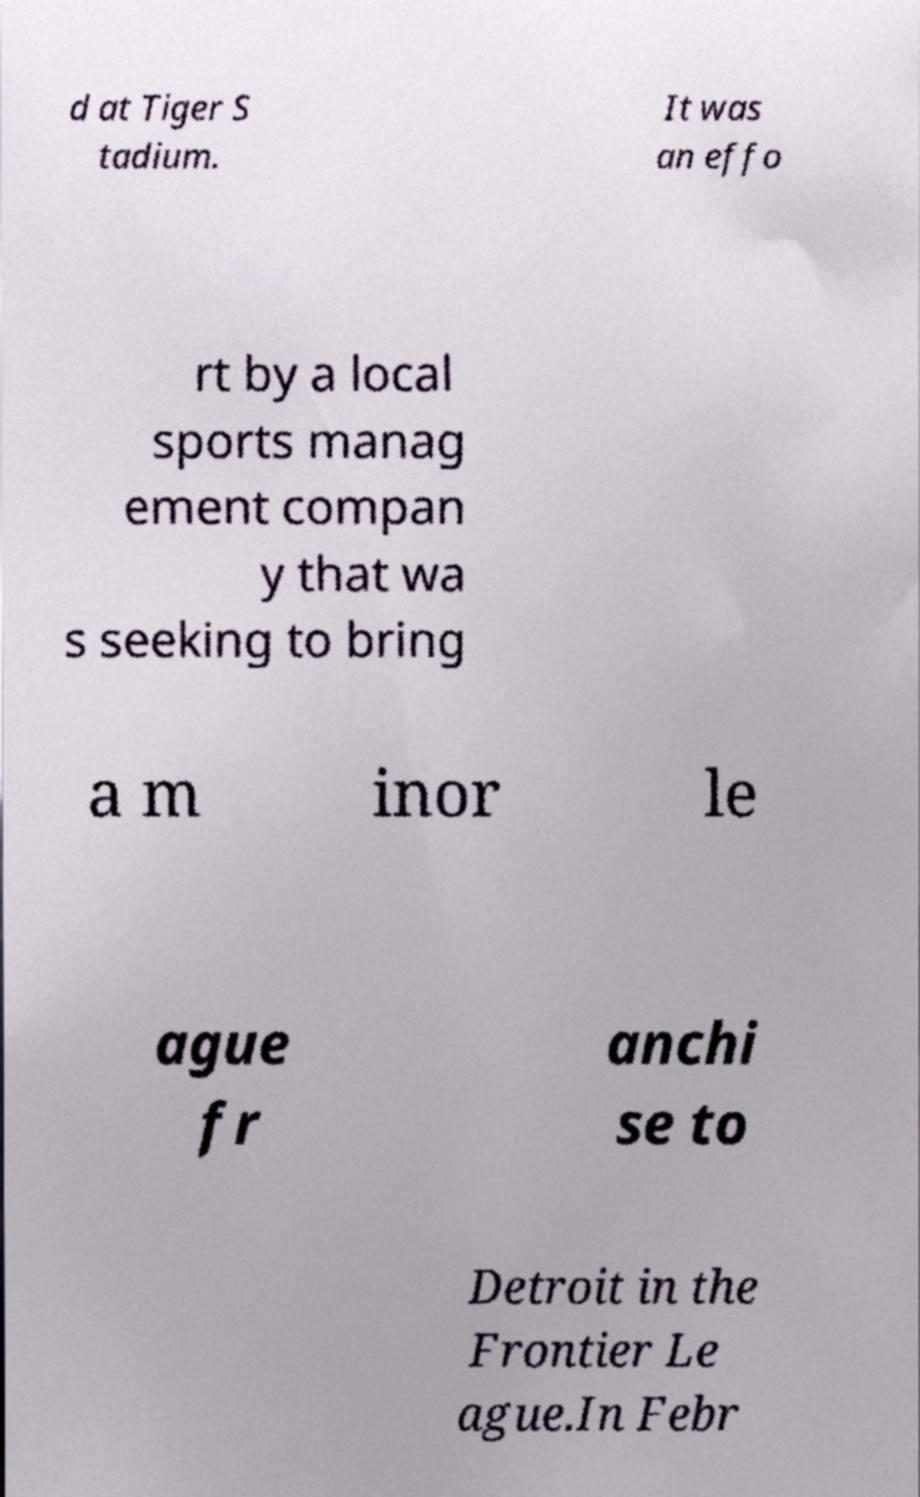What messages or text are displayed in this image? I need them in a readable, typed format. d at Tiger S tadium. It was an effo rt by a local sports manag ement compan y that wa s seeking to bring a m inor le ague fr anchi se to Detroit in the Frontier Le ague.In Febr 